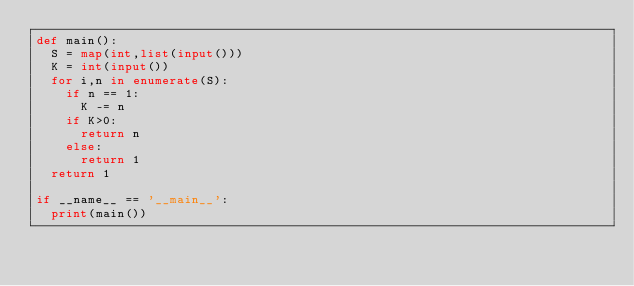<code> <loc_0><loc_0><loc_500><loc_500><_Python_>def main():
  S = map(int,list(input()))
  K = int(input())
  for i,n in enumerate(S):
    if n == 1:
      K -= n
    if K>0:
      return n
    else:
      return 1
  return 1

if __name__ == '__main__':
  print(main())
</code> 